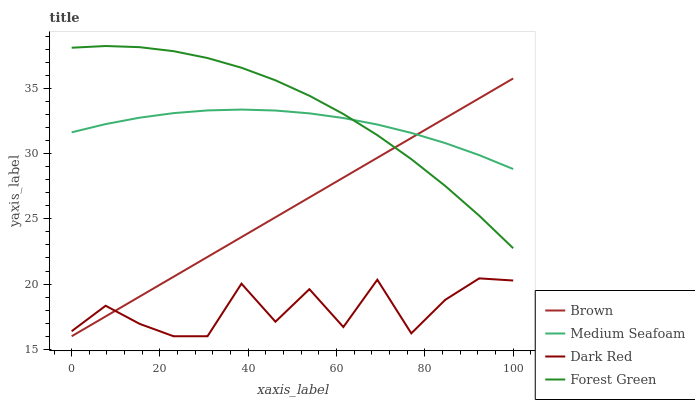Does Dark Red have the minimum area under the curve?
Answer yes or no. Yes. Does Forest Green have the maximum area under the curve?
Answer yes or no. Yes. Does Medium Seafoam have the minimum area under the curve?
Answer yes or no. No. Does Medium Seafoam have the maximum area under the curve?
Answer yes or no. No. Is Brown the smoothest?
Answer yes or no. Yes. Is Dark Red the roughest?
Answer yes or no. Yes. Is Forest Green the smoothest?
Answer yes or no. No. Is Forest Green the roughest?
Answer yes or no. No. Does Brown have the lowest value?
Answer yes or no. Yes. Does Forest Green have the lowest value?
Answer yes or no. No. Does Forest Green have the highest value?
Answer yes or no. Yes. Does Medium Seafoam have the highest value?
Answer yes or no. No. Is Dark Red less than Forest Green?
Answer yes or no. Yes. Is Medium Seafoam greater than Dark Red?
Answer yes or no. Yes. Does Medium Seafoam intersect Forest Green?
Answer yes or no. Yes. Is Medium Seafoam less than Forest Green?
Answer yes or no. No. Is Medium Seafoam greater than Forest Green?
Answer yes or no. No. Does Dark Red intersect Forest Green?
Answer yes or no. No. 